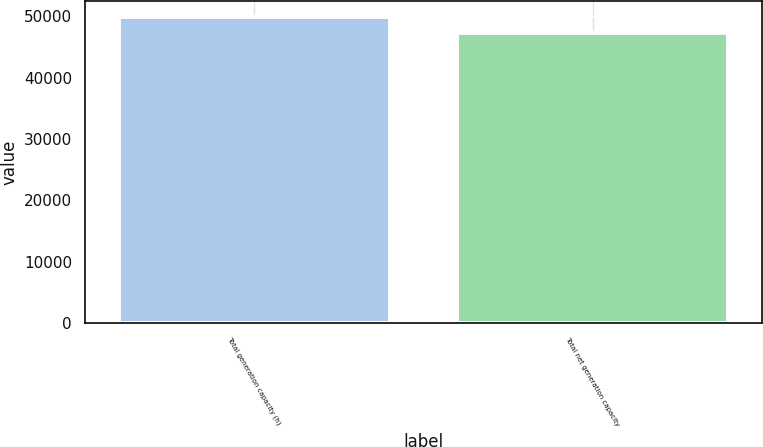Convert chart. <chart><loc_0><loc_0><loc_500><loc_500><bar_chart><fcel>Total generation capacity (h)<fcel>Total net generation capacity<nl><fcel>49964<fcel>47216<nl></chart> 